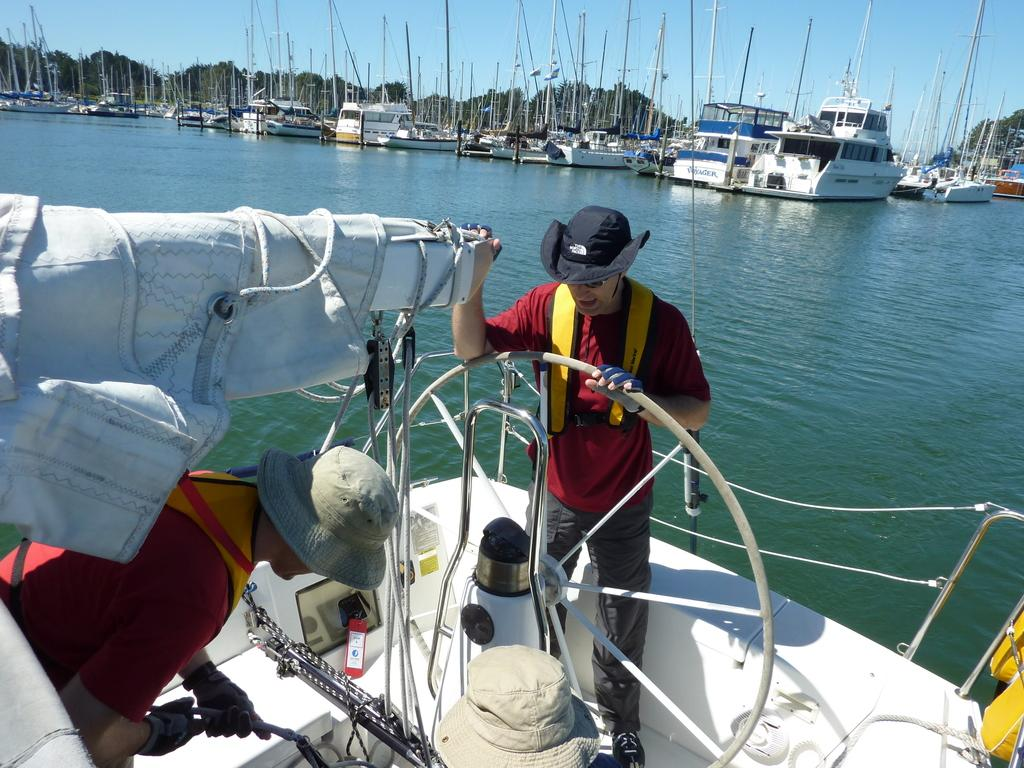What type of vehicles can be seen in the image? There are many watercraft in the image. What natural feature is visible in the background? The sea is visible in the image. Can you describe the people in the image? There are people in the image. What else can be seen in the sky? The sky is visible in the image. What type of vegetation is present in the image? There are many trees in the image. What type of shoes are the people wearing while walking on the road in the image? There is no road or shoes visible in the image; it features watercraft, the sea, people, sky, and trees. 